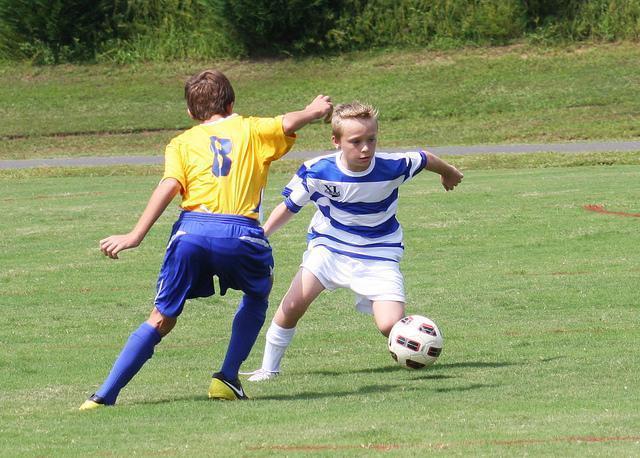How many players are wearing yellow?
Give a very brief answer. 1. How many people are there?
Give a very brief answer. 2. 